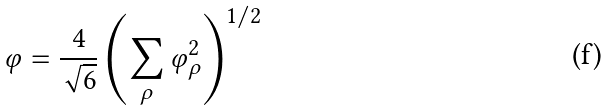Convert formula to latex. <formula><loc_0><loc_0><loc_500><loc_500>\varphi = \frac { 4 } { \sqrt { 6 } } \left ( \sum _ { \rho } \varphi _ { \rho } ^ { 2 } \right ) ^ { 1 / 2 }</formula> 